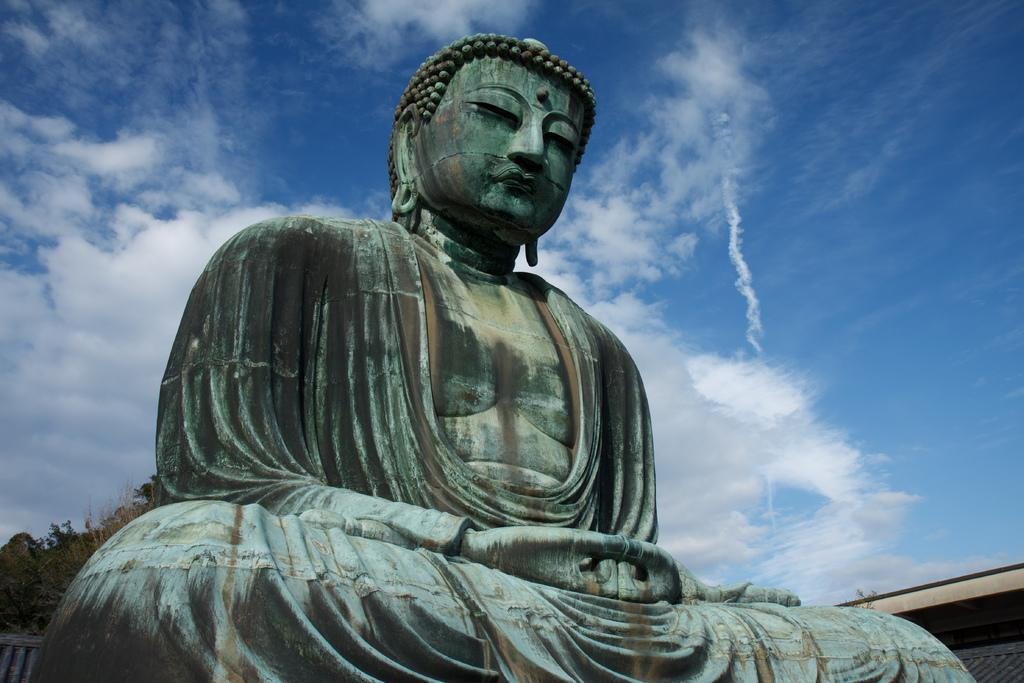What is the main subject in the image? There is a statue in the image. What can be seen in the background of the image? The sky is visible in the background of the image. Is the statue sinking into quicksand in the image? There is no quicksand present in the image, and the statue is not sinking. What type of destruction can be seen happening to the statue in the image? There is no destruction happening to the statue in the image; it appears to be intact. 